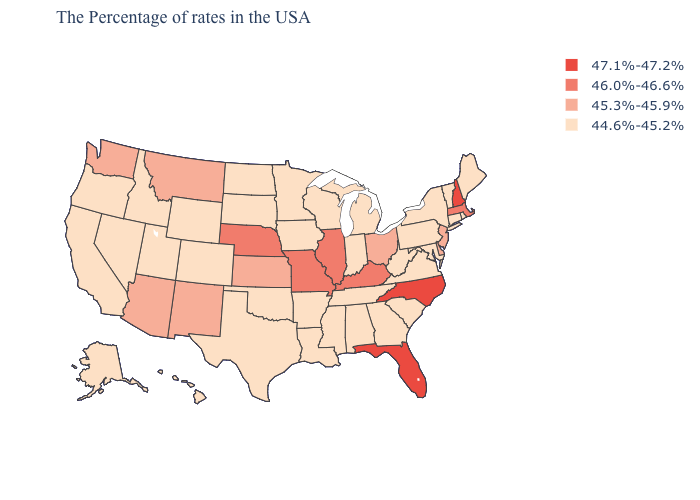Name the states that have a value in the range 44.6%-45.2%?
Concise answer only. Maine, Rhode Island, Vermont, Connecticut, New York, Maryland, Pennsylvania, Virginia, South Carolina, West Virginia, Georgia, Michigan, Indiana, Alabama, Tennessee, Wisconsin, Mississippi, Louisiana, Arkansas, Minnesota, Iowa, Oklahoma, Texas, South Dakota, North Dakota, Wyoming, Colorado, Utah, Idaho, Nevada, California, Oregon, Alaska, Hawaii. Which states have the lowest value in the USA?
Short answer required. Maine, Rhode Island, Vermont, Connecticut, New York, Maryland, Pennsylvania, Virginia, South Carolina, West Virginia, Georgia, Michigan, Indiana, Alabama, Tennessee, Wisconsin, Mississippi, Louisiana, Arkansas, Minnesota, Iowa, Oklahoma, Texas, South Dakota, North Dakota, Wyoming, Colorado, Utah, Idaho, Nevada, California, Oregon, Alaska, Hawaii. What is the value of Oregon?
Short answer required. 44.6%-45.2%. Name the states that have a value in the range 45.3%-45.9%?
Answer briefly. New Jersey, Delaware, Ohio, Kansas, New Mexico, Montana, Arizona, Washington. What is the value of Florida?
Be succinct. 47.1%-47.2%. What is the value of Tennessee?
Answer briefly. 44.6%-45.2%. Does North Carolina have the lowest value in the South?
Short answer required. No. Does the first symbol in the legend represent the smallest category?
Quick response, please. No. Name the states that have a value in the range 47.1%-47.2%?
Write a very short answer. New Hampshire, North Carolina, Florida. Name the states that have a value in the range 44.6%-45.2%?
Answer briefly. Maine, Rhode Island, Vermont, Connecticut, New York, Maryland, Pennsylvania, Virginia, South Carolina, West Virginia, Georgia, Michigan, Indiana, Alabama, Tennessee, Wisconsin, Mississippi, Louisiana, Arkansas, Minnesota, Iowa, Oklahoma, Texas, South Dakota, North Dakota, Wyoming, Colorado, Utah, Idaho, Nevada, California, Oregon, Alaska, Hawaii. Does the map have missing data?
Be succinct. No. Which states have the highest value in the USA?
Write a very short answer. New Hampshire, North Carolina, Florida. Name the states that have a value in the range 45.3%-45.9%?
Write a very short answer. New Jersey, Delaware, Ohio, Kansas, New Mexico, Montana, Arizona, Washington. How many symbols are there in the legend?
Short answer required. 4. What is the lowest value in the Northeast?
Answer briefly. 44.6%-45.2%. 